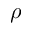Convert formula to latex. <formula><loc_0><loc_0><loc_500><loc_500>\rho</formula> 